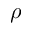Convert formula to latex. <formula><loc_0><loc_0><loc_500><loc_500>\rho</formula> 